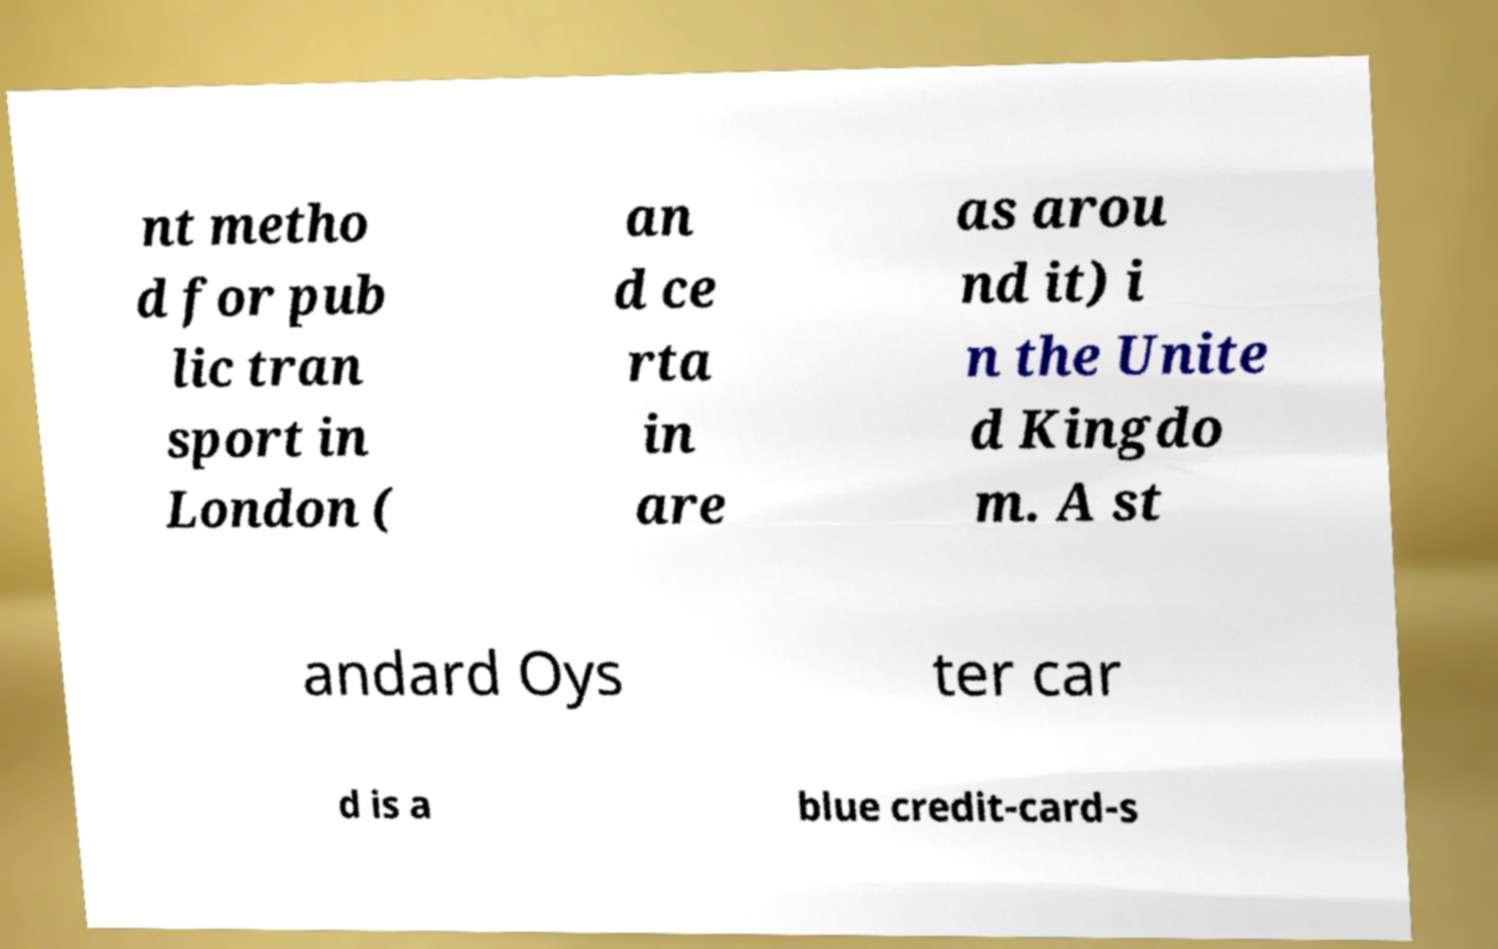Can you read and provide the text displayed in the image?This photo seems to have some interesting text. Can you extract and type it out for me? nt metho d for pub lic tran sport in London ( an d ce rta in are as arou nd it) i n the Unite d Kingdo m. A st andard Oys ter car d is a blue credit-card-s 